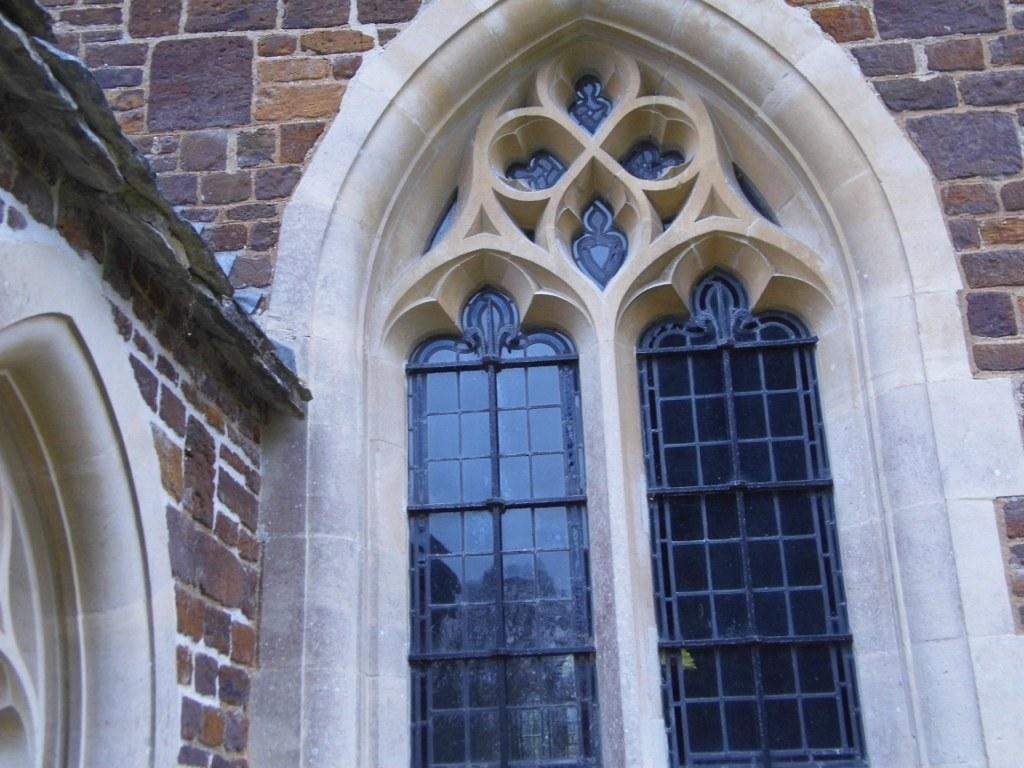What type of structure is present in the image? There is a building in the image. How many windows can be seen on the building? The building has two windows. What is above the windows on the building? There is an arch with a design above the windows. What part of the building is visible in the image? The wall of the building is visible. What is the tax rate for the building in the image? There is no information about tax rates in the image, as it only shows a building with two windows and an arch. 